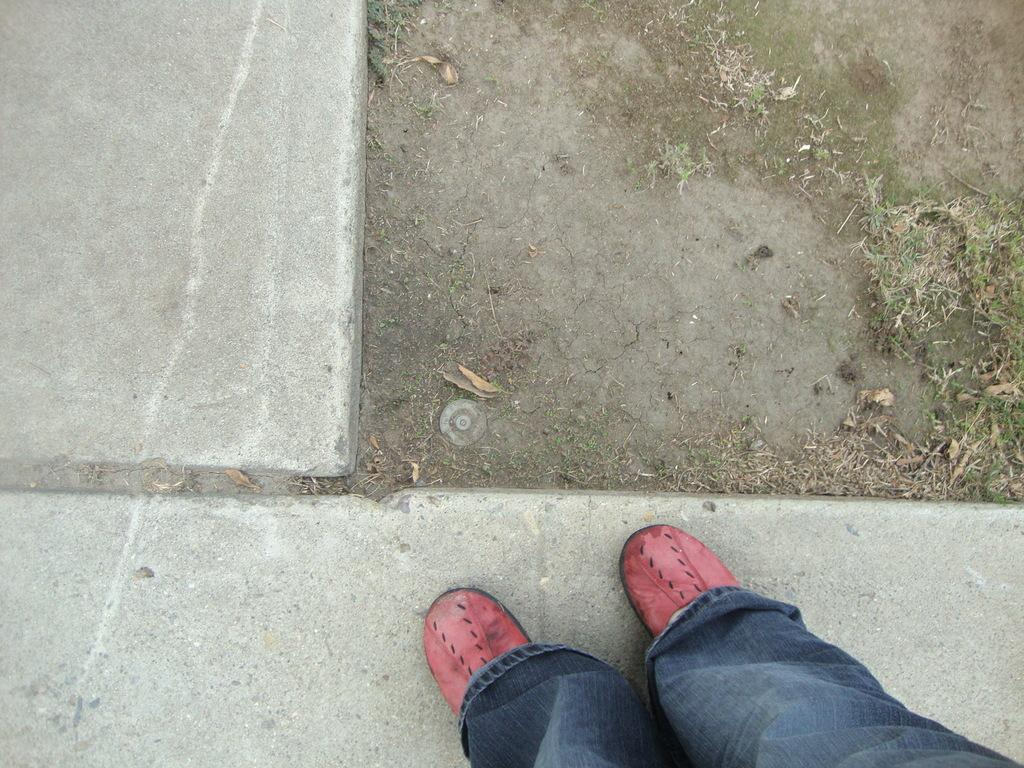What part of a person can be seen in the image? There are legs of a person visible in the image. Where are the legs located? The legs are on a walkway. What type of vegetation is present in the image? There is grass in the image. How many babies are crawling on the actor in the image? There are no babies or actors present in the image; it only shows legs on a walkway with grass. 